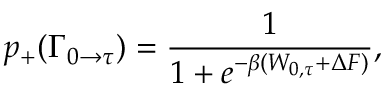Convert formula to latex. <formula><loc_0><loc_0><loc_500><loc_500>p _ { + } ( \Gamma _ { 0 \rightarrow \tau } ) = \frac { 1 } { 1 + e ^ { - \beta ( W _ { 0 , \tau } + \Delta F ) } } ,</formula> 